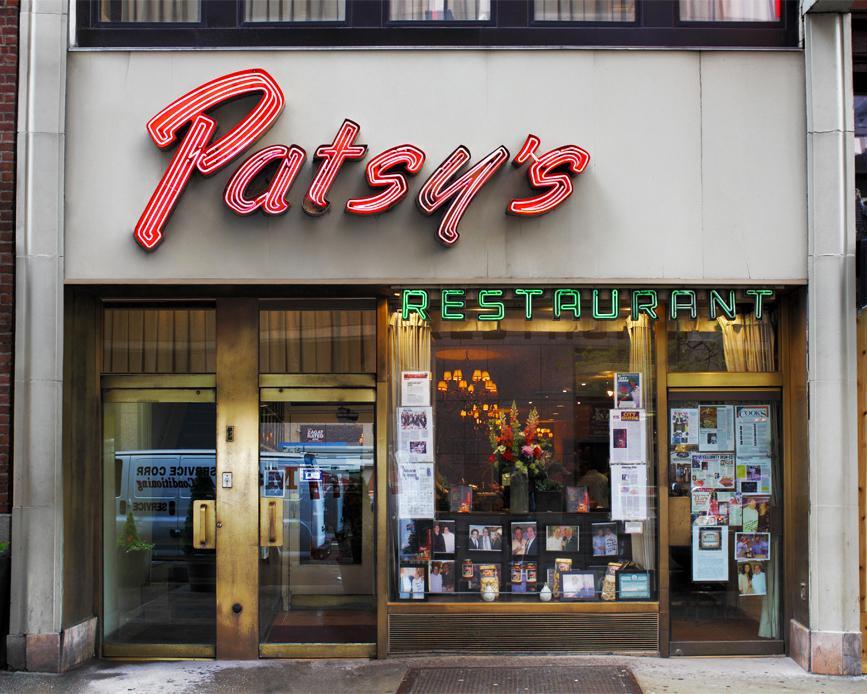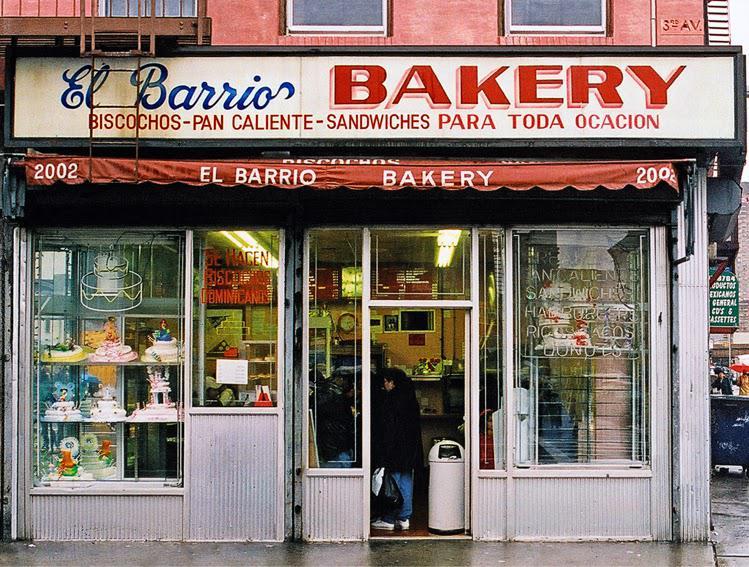The first image is the image on the left, the second image is the image on the right. Given the left and right images, does the statement "There are two set of red bookshelves outside filled with books, under a red awning." hold true? Answer yes or no. No. 